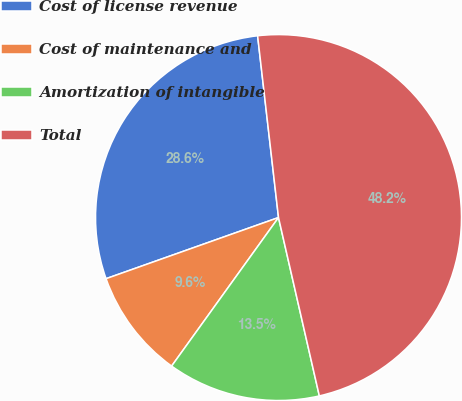<chart> <loc_0><loc_0><loc_500><loc_500><pie_chart><fcel>Cost of license revenue<fcel>Cost of maintenance and<fcel>Amortization of intangible<fcel>Total<nl><fcel>28.6%<fcel>9.65%<fcel>13.51%<fcel>48.24%<nl></chart> 